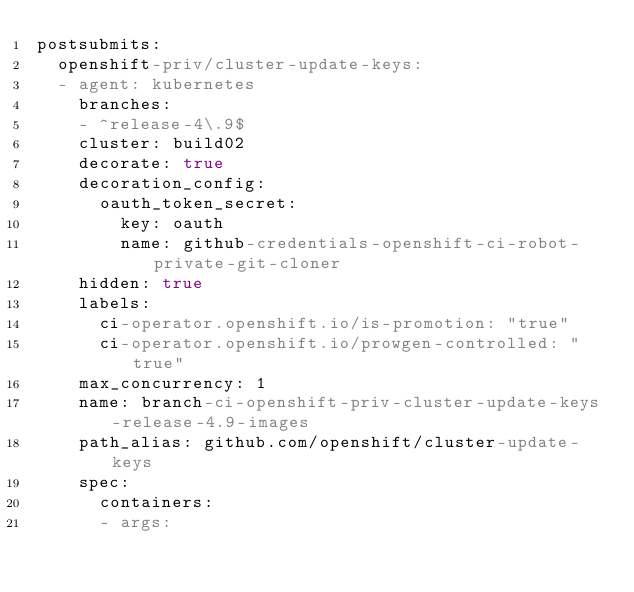<code> <loc_0><loc_0><loc_500><loc_500><_YAML_>postsubmits:
  openshift-priv/cluster-update-keys:
  - agent: kubernetes
    branches:
    - ^release-4\.9$
    cluster: build02
    decorate: true
    decoration_config:
      oauth_token_secret:
        key: oauth
        name: github-credentials-openshift-ci-robot-private-git-cloner
    hidden: true
    labels:
      ci-operator.openshift.io/is-promotion: "true"
      ci-operator.openshift.io/prowgen-controlled: "true"
    max_concurrency: 1
    name: branch-ci-openshift-priv-cluster-update-keys-release-4.9-images
    path_alias: github.com/openshift/cluster-update-keys
    spec:
      containers:
      - args:</code> 